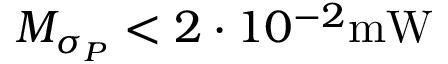<formula> <loc_0><loc_0><loc_500><loc_500>M _ { \sigma _ { P } } < 2 \cdot 1 0 ^ { - 2 } m W</formula> 